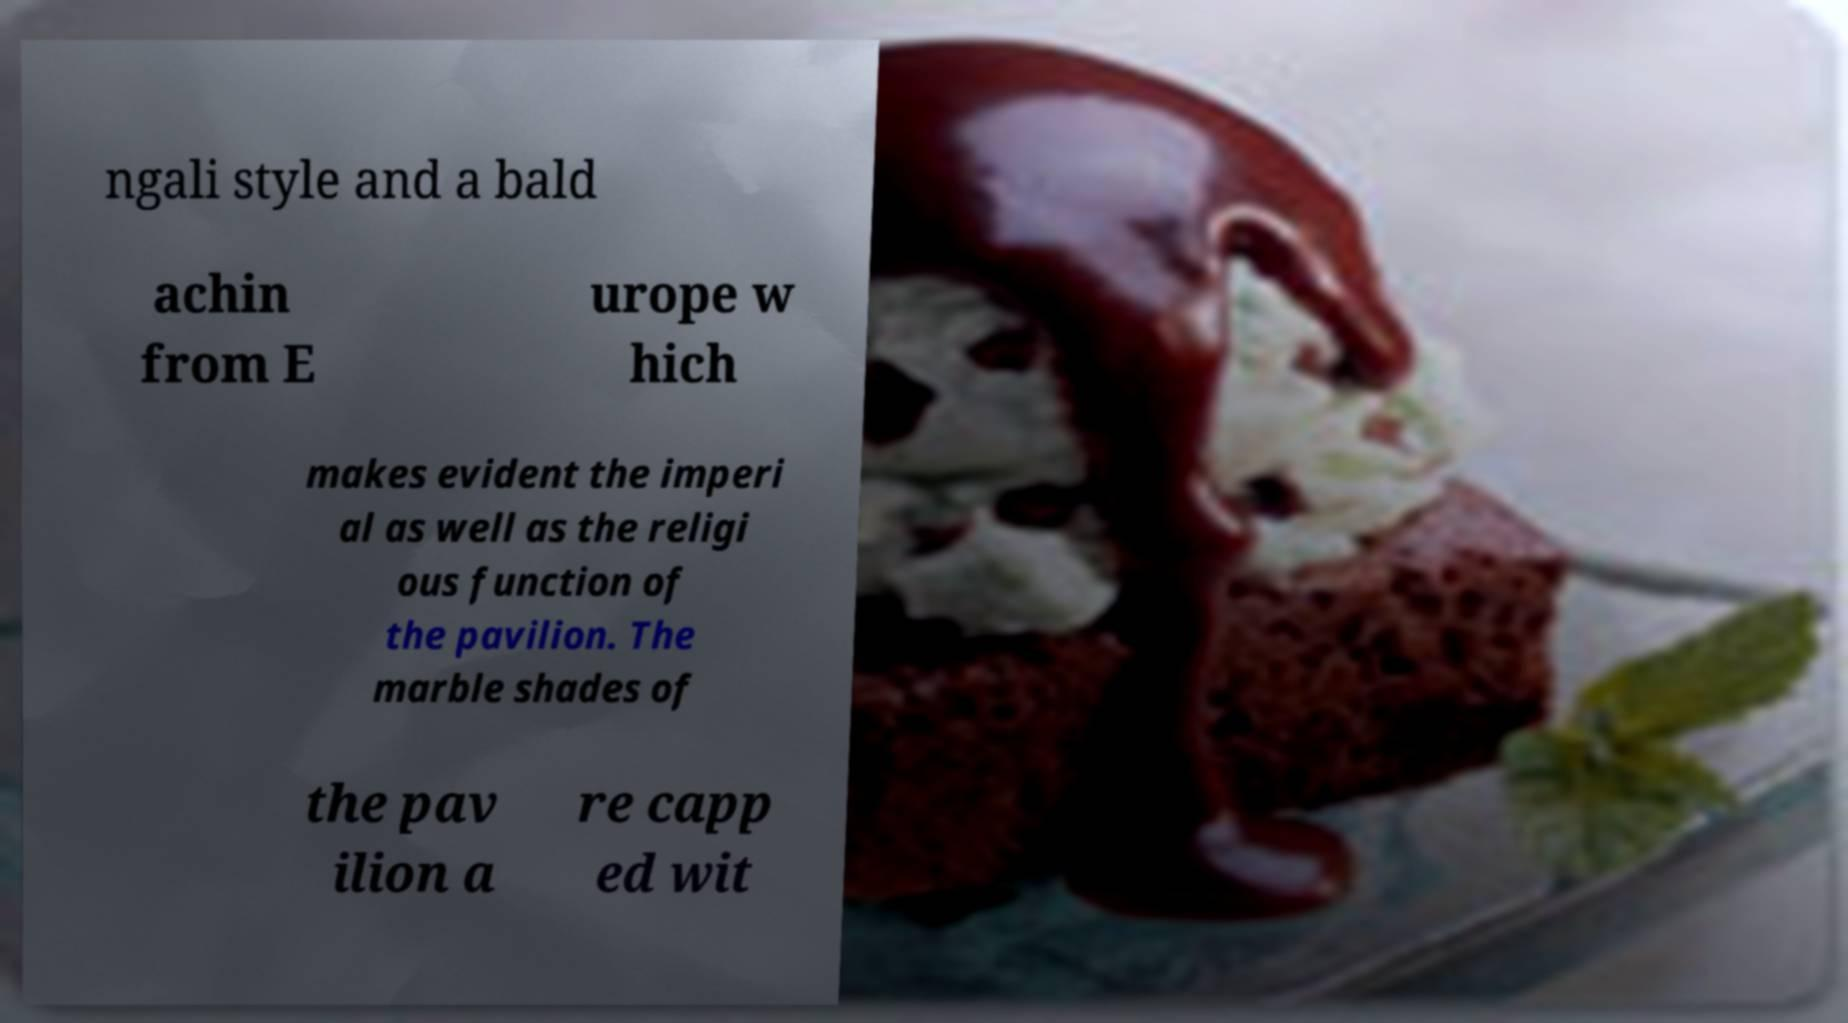Could you assist in decoding the text presented in this image and type it out clearly? ngali style and a bald achin from E urope w hich makes evident the imperi al as well as the religi ous function of the pavilion. The marble shades of the pav ilion a re capp ed wit 